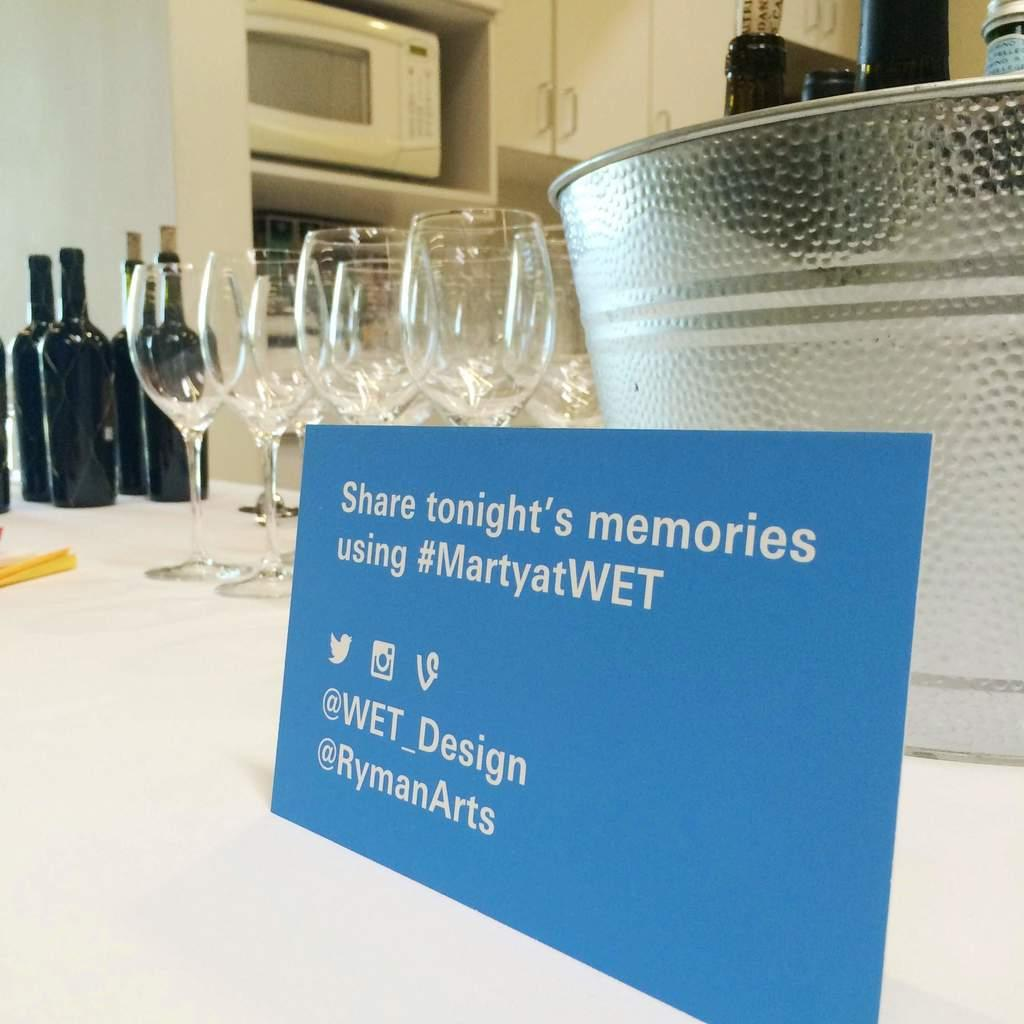<image>
Write a terse but informative summary of the picture. the word share is on a blue sign 